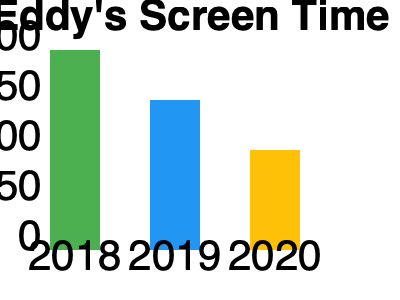Based on the bar chart showing Sonya Eddy's screen time on General Hospital, what was the trend in her appearance from 2018 to 2020, and by how many hours did her screen time decrease between 2018 and 2020? To answer this question, let's analyze the bar chart step by step:

1. Identify the years and corresponding screen time:
   - 2018: 200 hours
   - 2019: 150 hours
   - 2020: 100 hours

2. Observe the trend:
   The bars show a consistent decrease in screen time from 2018 to 2020.

3. Calculate the total decrease from 2018 to 2020:
   Decrease = 2018 screen time - 2020 screen time
   Decrease = 200 hours - 100 hours = 100 hours

Therefore, Sonya Eddy's screen time on General Hospital showed a decreasing trend from 2018 to 2020, with a total decrease of 100 hours over this period.
Answer: Decreasing trend; 100 hours decrease 